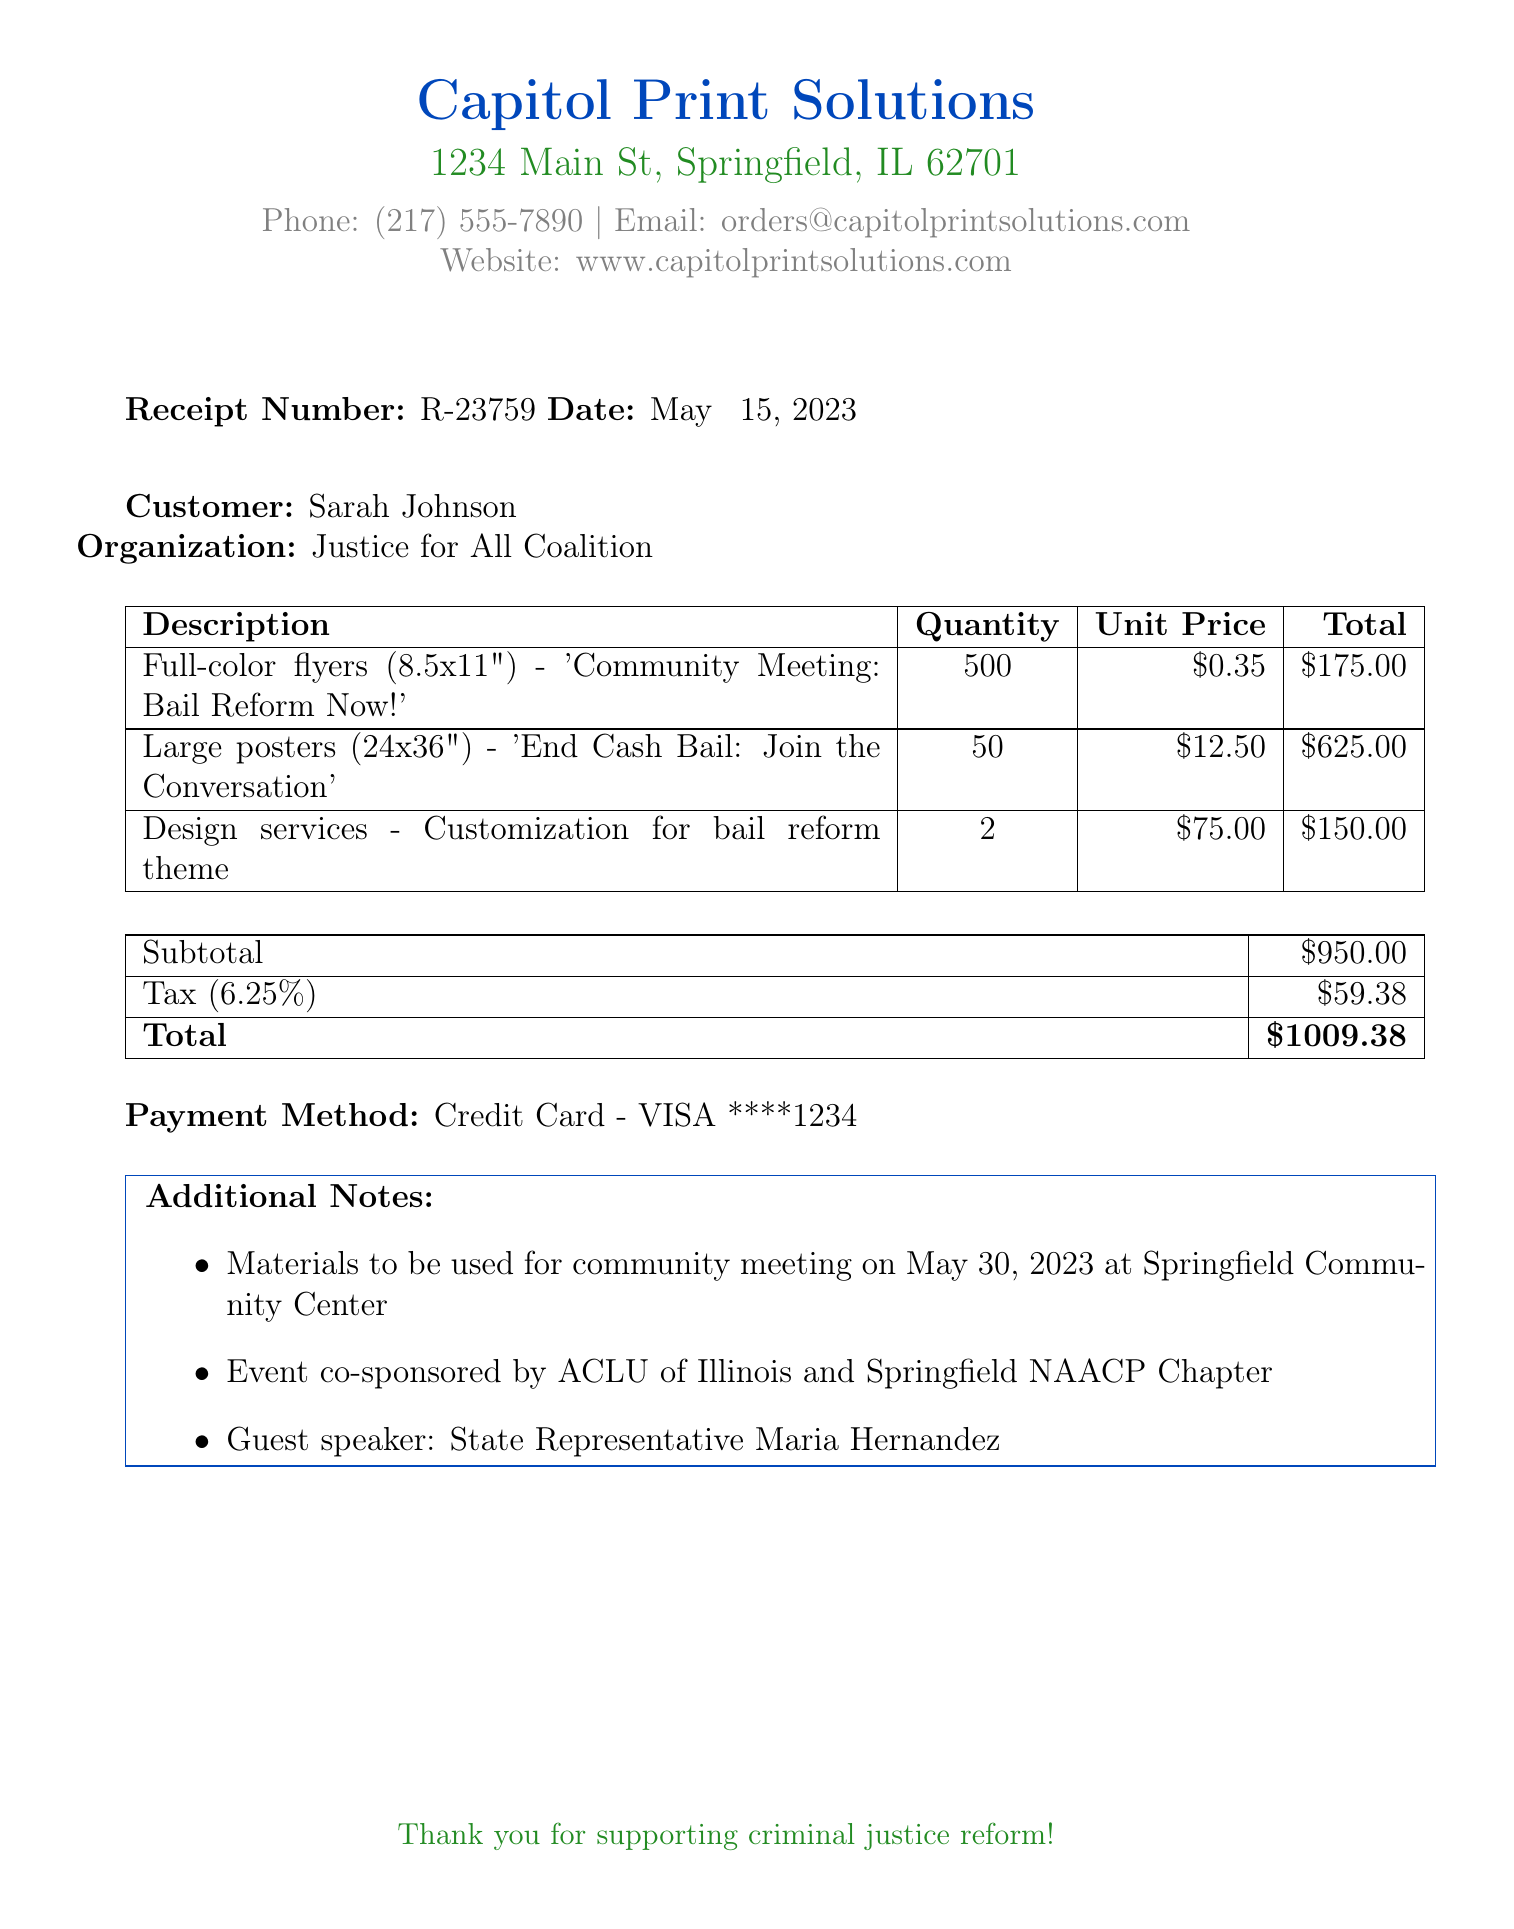What is the receipt number? The receipt number is listed in the document as a unique identifier for this transaction.
Answer: R-23759 What is the date of the transaction? The date is provided in the document which specifies when the receipt was issued.
Answer: May 15, 2023 What is the total amount charged? The total amount reflects the sum after applying taxes on the subtotal from the printing services.
Answer: $1009.38 Who is the guest speaker at the community meeting? The document mentions the guest speaker regarding the event details in the additional notes section.
Answer: State Representative Maria Hernandez What type of payment was used? The payment method is clearly indicated in the payment section of the receipt.
Answer: Credit Card - VISA ****1234 How many flyers were printed? The quantity of flyers printed is explicitly stated in the itemized list on the receipt.
Answer: 500 What is the subtotal before tax? The subtotal is the sum of all itemized services before tax is applied, mentioned in the financial section.
Answer: $950.00 What is the tax rate applied? The tax rate provides insight into how the total amount was calculated, which is listed in the receipt.
Answer: 6.25% What event is being promoted with these materials? The purpose of the printed materials is discussed in the additional notes and reflects the theme of the event.
Answer: Community Meeting on May 30, 2023 